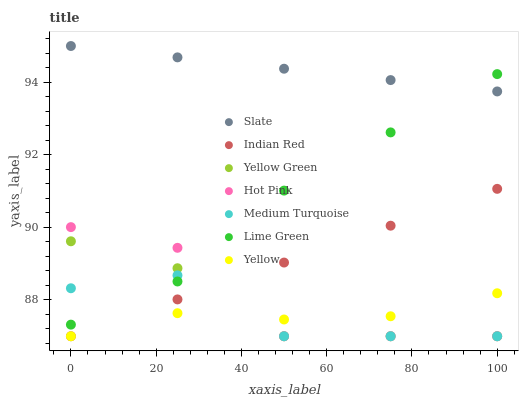Does Yellow have the minimum area under the curve?
Answer yes or no. Yes. Does Slate have the maximum area under the curve?
Answer yes or no. Yes. Does Yellow Green have the minimum area under the curve?
Answer yes or no. No. Does Yellow Green have the maximum area under the curve?
Answer yes or no. No. Is Indian Red the smoothest?
Answer yes or no. Yes. Is Hot Pink the roughest?
Answer yes or no. Yes. Is Yellow Green the smoothest?
Answer yes or no. No. Is Yellow Green the roughest?
Answer yes or no. No. Does Medium Turquoise have the lowest value?
Answer yes or no. Yes. Does Slate have the lowest value?
Answer yes or no. No. Does Slate have the highest value?
Answer yes or no. Yes. Does Yellow Green have the highest value?
Answer yes or no. No. Is Indian Red less than Lime Green?
Answer yes or no. Yes. Is Slate greater than Medium Turquoise?
Answer yes or no. Yes. Does Hot Pink intersect Lime Green?
Answer yes or no. Yes. Is Hot Pink less than Lime Green?
Answer yes or no. No. Is Hot Pink greater than Lime Green?
Answer yes or no. No. Does Indian Red intersect Lime Green?
Answer yes or no. No. 